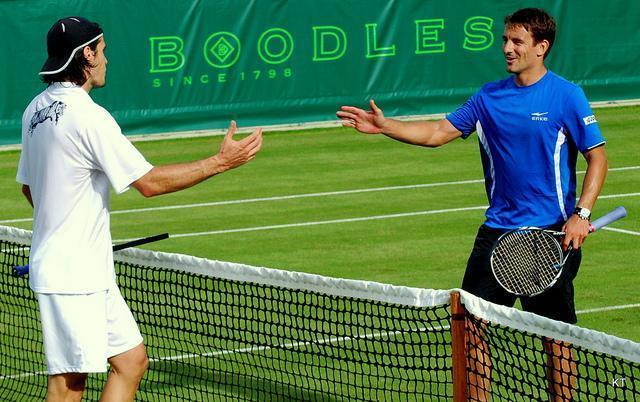How many people are there?
Give a very brief answer. 2. 